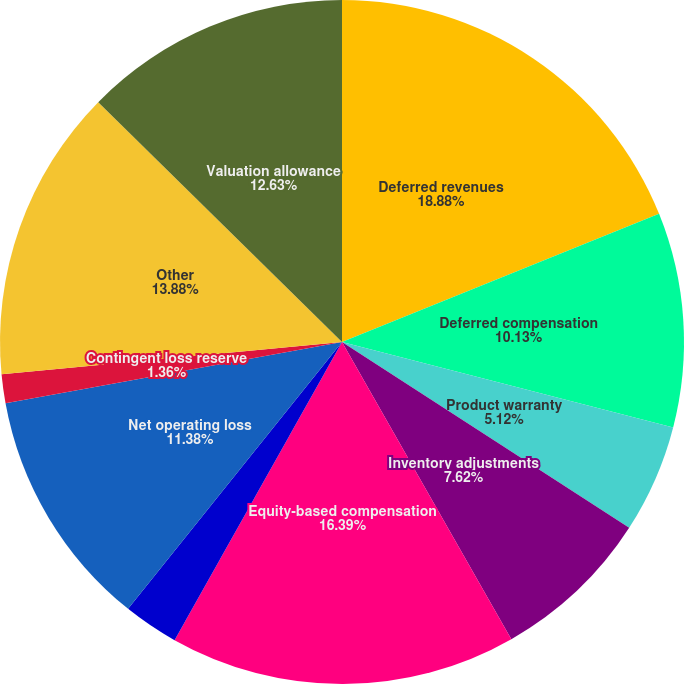Convert chart. <chart><loc_0><loc_0><loc_500><loc_500><pie_chart><fcel>Deferred revenues<fcel>Deferred compensation<fcel>Product warranty<fcel>Inventory adjustments<fcel>Equity-based compensation<fcel>Environmental reserve<fcel>Net operating loss<fcel>Contingent loss reserve<fcel>Other<fcel>Valuation allowance<nl><fcel>18.89%<fcel>10.13%<fcel>5.12%<fcel>7.62%<fcel>16.39%<fcel>2.61%<fcel>11.38%<fcel>1.36%<fcel>13.88%<fcel>12.63%<nl></chart> 